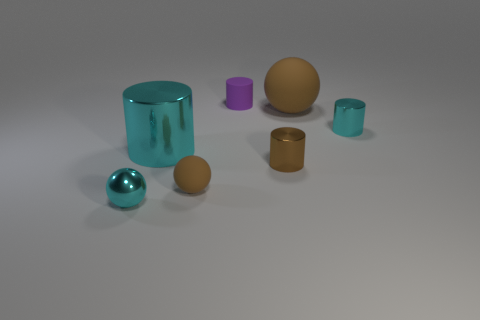What number of large purple matte cylinders are there? 0 